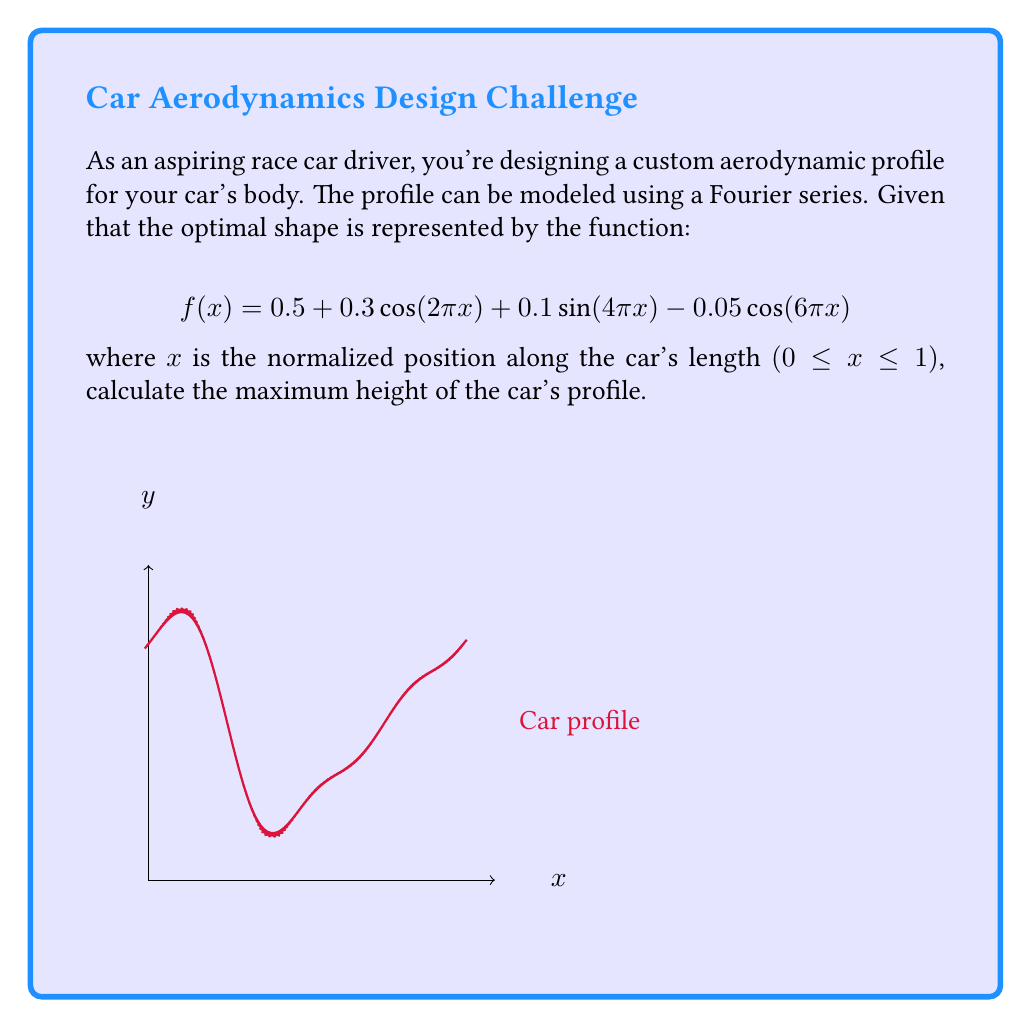Teach me how to tackle this problem. To find the maximum height of the car's profile, we need to follow these steps:

1) The given function is a sum of periodic functions:
   $$f(x) = 0.5 + 0.3\cos(2\pi x) + 0.1\sin(4\pi x) - 0.05\cos(6\pi x)$$

2) The constant term 0.5 shifts the function upward.

3) The maximum value of cosine and sine functions is 1, and their minimum is -1.

4) To find the maximum possible value of $f(x)$, we need to consider the maximum positive contribution from each term:
   
   - $0.5$ is constant
   - $0.3\cos(2\pi x)$ can contribute at most 0.3
   - $0.1\sin(4\pi x)$ can contribute at most 0.1
   - $-0.05\cos(6\pi x)$ can contribute at most 0.05 (when cosine is at its minimum, -1)

5) Therefore, the maximum possible value is:
   $$f_{max} = 0.5 + 0.3 + 0.1 + 0.05 = 0.95$$

This occurs when $\cos(2\pi x) = 1$, $\sin(4\pi x) = 1$, and $\cos(6\pi x) = -1$ simultaneously.
Answer: 0.95 